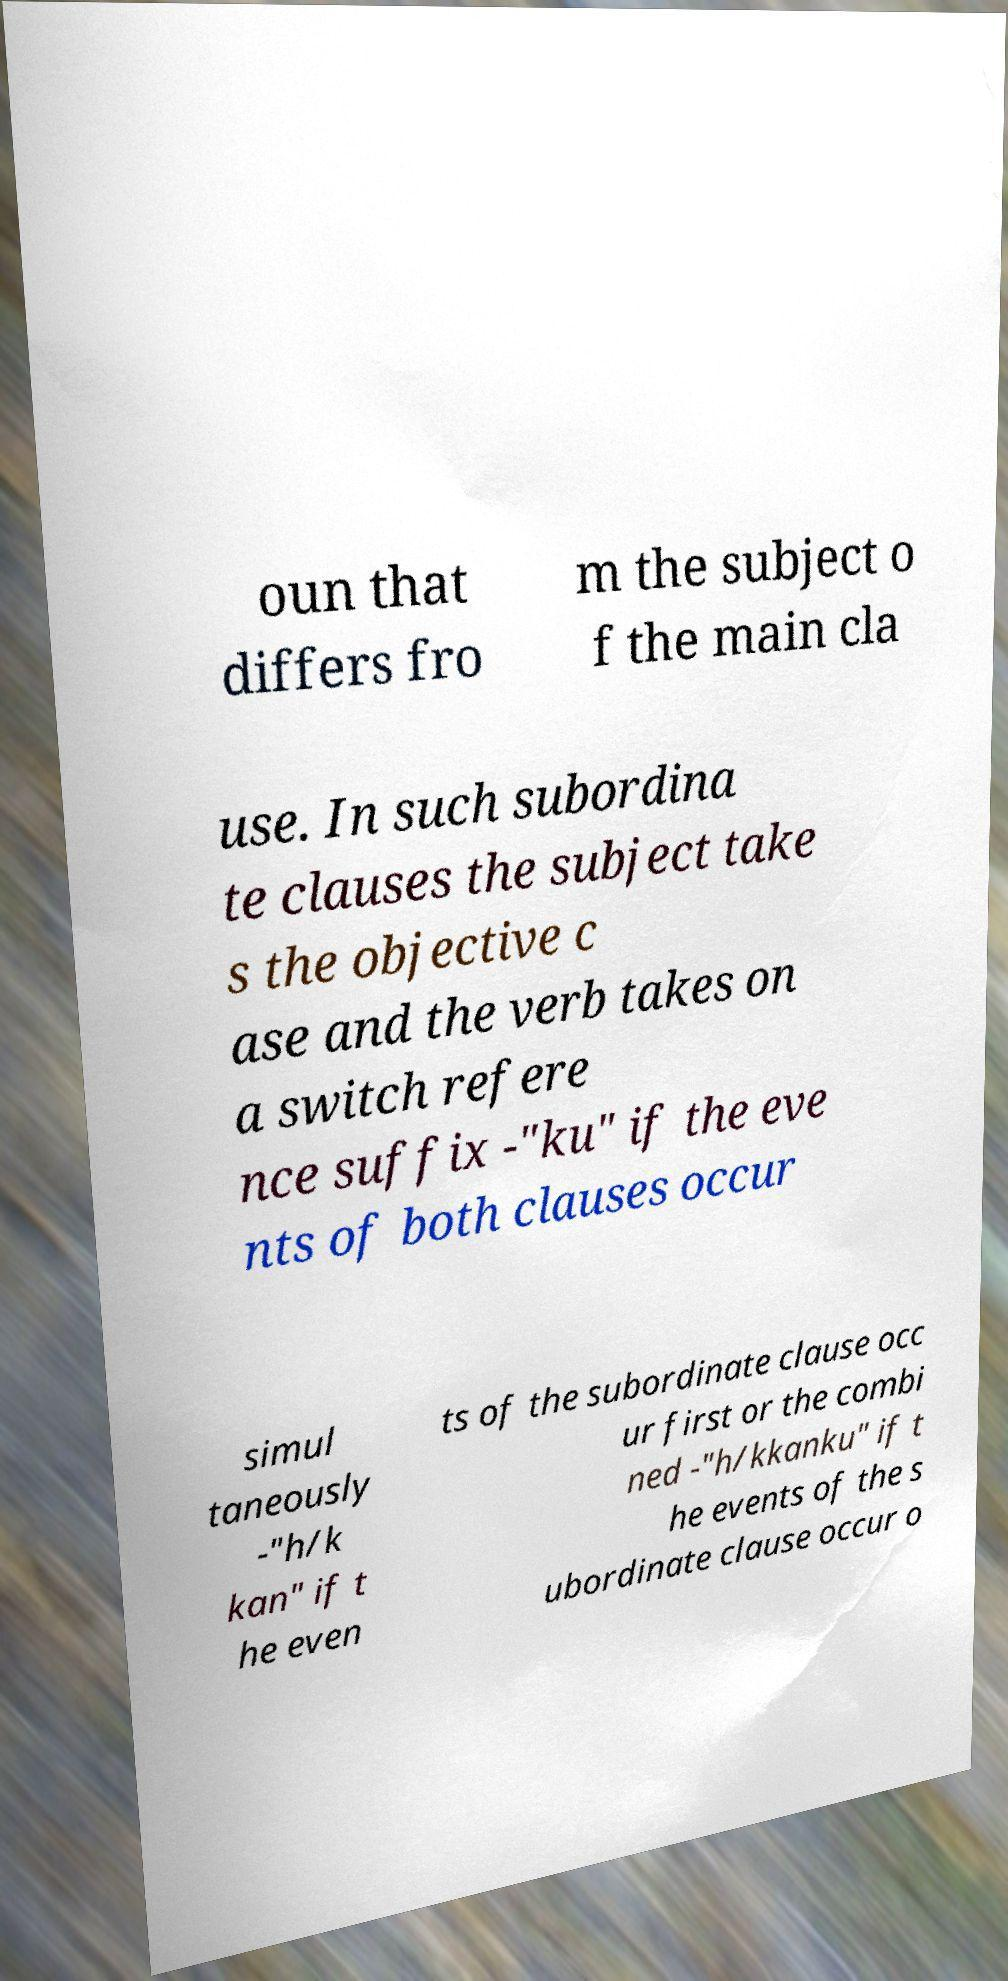There's text embedded in this image that I need extracted. Can you transcribe it verbatim? oun that differs fro m the subject o f the main cla use. In such subordina te clauses the subject take s the objective c ase and the verb takes on a switch refere nce suffix -"ku" if the eve nts of both clauses occur simul taneously -"h/k kan" if t he even ts of the subordinate clause occ ur first or the combi ned -"h/kkanku" if t he events of the s ubordinate clause occur o 